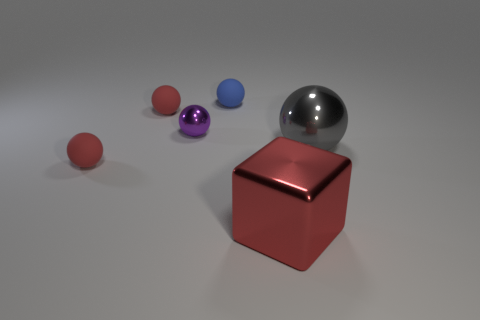Is the size of the gray shiny ball the same as the metallic sphere to the left of the blue sphere?
Ensure brevity in your answer.  No. How many tiny objects are on the left side of the tiny thing that is right of the metallic object on the left side of the blue ball?
Your response must be concise. 3. Are there any red things in front of the large red metal object?
Provide a short and direct response. No. What is the shape of the red metallic thing?
Ensure brevity in your answer.  Cube. What is the shape of the small red thing that is right of the red matte object in front of the big object on the right side of the large red object?
Make the answer very short. Sphere. How many other objects are the same shape as the tiny purple thing?
Keep it short and to the point. 4. The red thing behind the metal thing behind the large gray sphere is made of what material?
Give a very brief answer. Rubber. Are the big sphere and the small sphere that is in front of the purple metal thing made of the same material?
Keep it short and to the point. No. There is a object that is both behind the purple metal object and left of the small metallic object; what material is it?
Keep it short and to the point. Rubber. What is the color of the tiny rubber ball that is in front of the gray thing in front of the purple shiny thing?
Ensure brevity in your answer.  Red. 